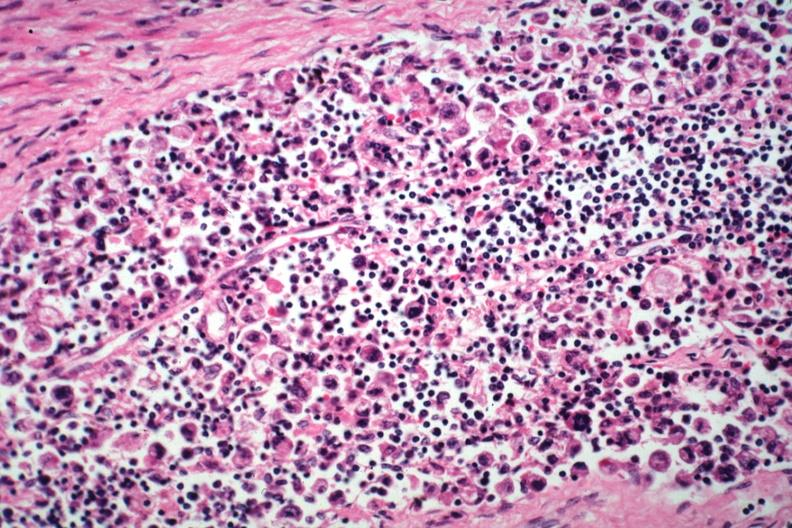how many cm does this image show hepatic node anaplastic adenocarcinoma from a sessile prepyloric polyp incidental finding died with promyelocytic leukemia stomach lesion #?
Answer the question using a single word or phrase. One 